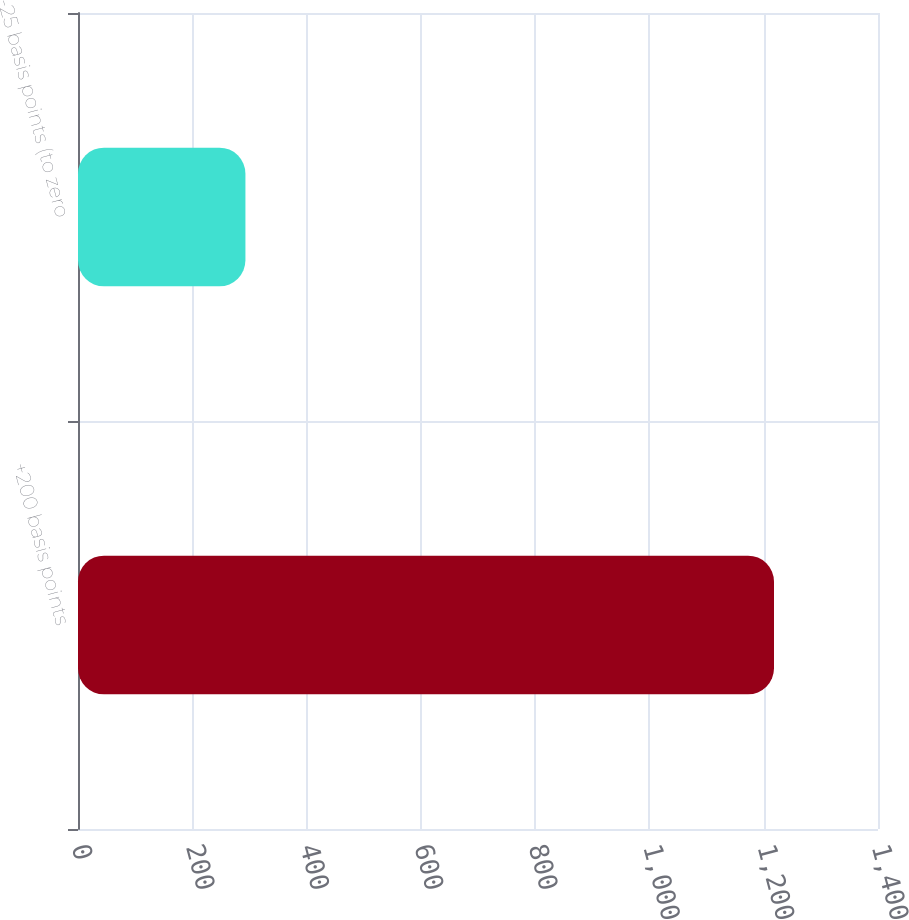Convert chart. <chart><loc_0><loc_0><loc_500><loc_500><bar_chart><fcel>+200 basis points<fcel>-25 basis points (to zero<nl><fcel>1218<fcel>293<nl></chart> 